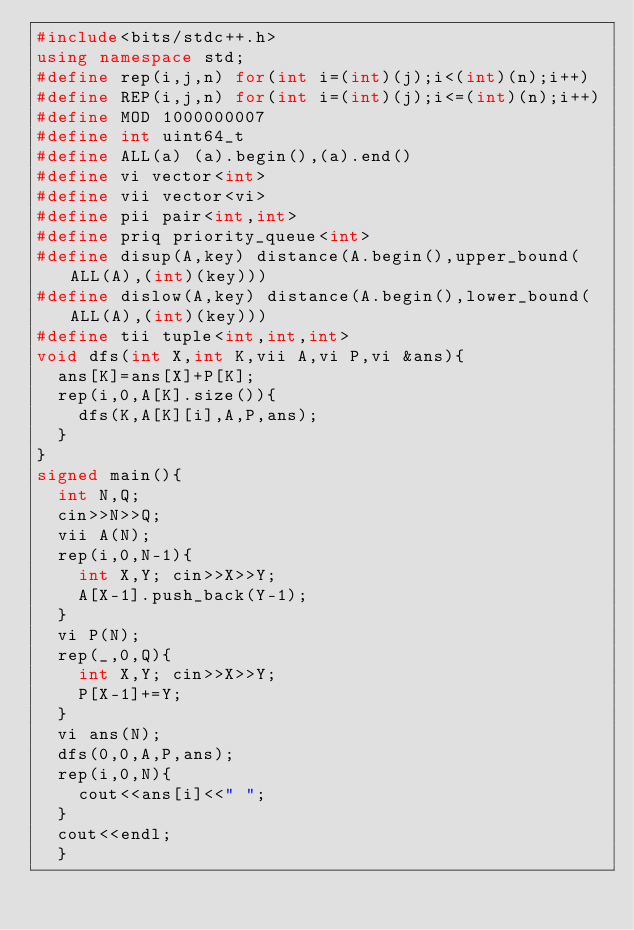Convert code to text. <code><loc_0><loc_0><loc_500><loc_500><_C++_>#include<bits/stdc++.h>
using namespace std;
#define rep(i,j,n) for(int i=(int)(j);i<(int)(n);i++)
#define REP(i,j,n) for(int i=(int)(j);i<=(int)(n);i++)
#define MOD 1000000007
#define int uint64_t
#define ALL(a) (a).begin(),(a).end()
#define vi vector<int>
#define vii vector<vi>
#define pii pair<int,int>
#define priq priority_queue<int>
#define disup(A,key) distance(A.begin(),upper_bound(ALL(A),(int)(key)))
#define dislow(A,key) distance(A.begin(),lower_bound(ALL(A),(int)(key)))
#define tii tuple<int,int,int>
void dfs(int X,int K,vii A,vi P,vi &ans){
  ans[K]=ans[X]+P[K];
  rep(i,0,A[K].size()){
    dfs(K,A[K][i],A,P,ans);
  }
}
signed main(){
  int N,Q;
  cin>>N>>Q;
  vii A(N);
  rep(i,0,N-1){
    int X,Y; cin>>X>>Y;
    A[X-1].push_back(Y-1);
  }
  vi P(N);
  rep(_,0,Q){
    int X,Y; cin>>X>>Y;
    P[X-1]+=Y;
  }
  vi ans(N);
  dfs(0,0,A,P,ans);
  rep(i,0,N){
    cout<<ans[i]<<" ";
  }
  cout<<endl;
  }


</code> 